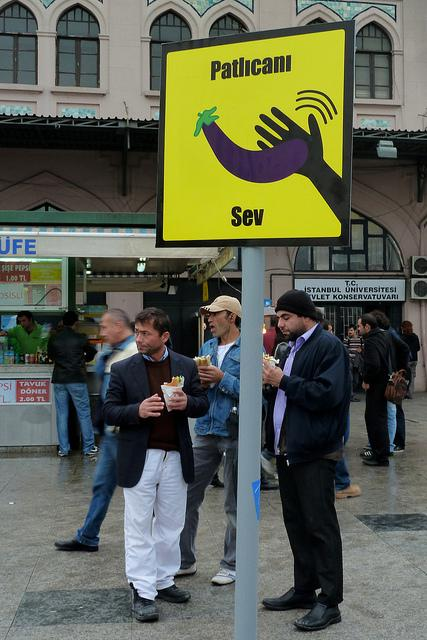What great empire once ruled this land? Please explain your reasoning. ottoman. The ottoman empire used to rule in this region of the world. 